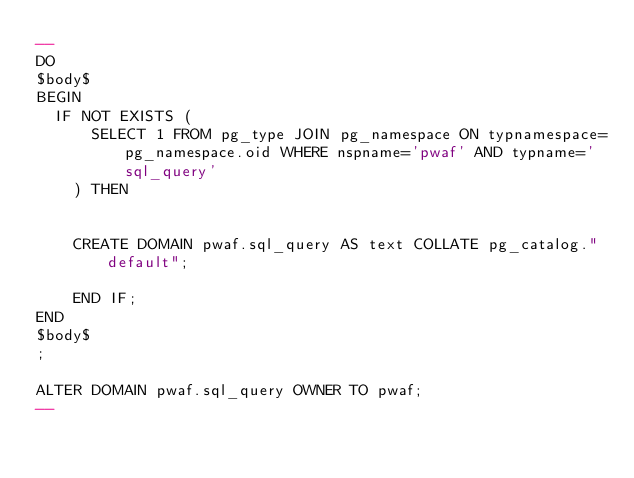<code> <loc_0><loc_0><loc_500><loc_500><_SQL_>--
DO
$body$
BEGIN
	IF NOT EXISTS (
    	SELECT 1 FROM pg_type JOIN pg_namespace ON typnamespace=pg_namespace.oid WHERE nspname='pwaf' AND typname='sql_query'
    ) THEN
    	

		CREATE DOMAIN pwaf.sql_query AS text COLLATE pg_catalog."default";

   	END IF;
END
$body$
;

ALTER DOMAIN pwaf.sql_query OWNER TO pwaf;
--</code> 